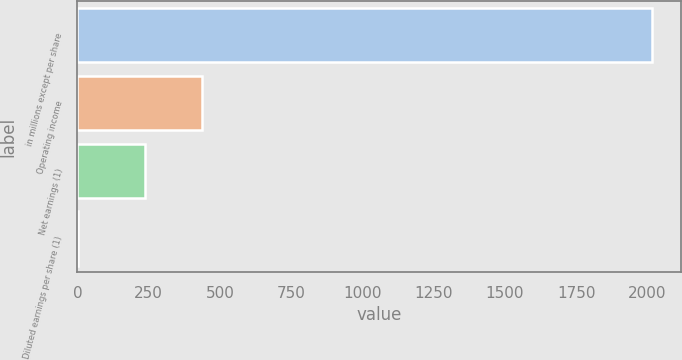Convert chart to OTSL. <chart><loc_0><loc_0><loc_500><loc_500><bar_chart><fcel>in millions except per share<fcel>Operating income<fcel>Net earnings (1)<fcel>Diluted earnings per share (1)<nl><fcel>2017<fcel>437.57<fcel>236<fcel>1.34<nl></chart> 